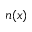Convert formula to latex. <formula><loc_0><loc_0><loc_500><loc_500>n ( x )</formula> 